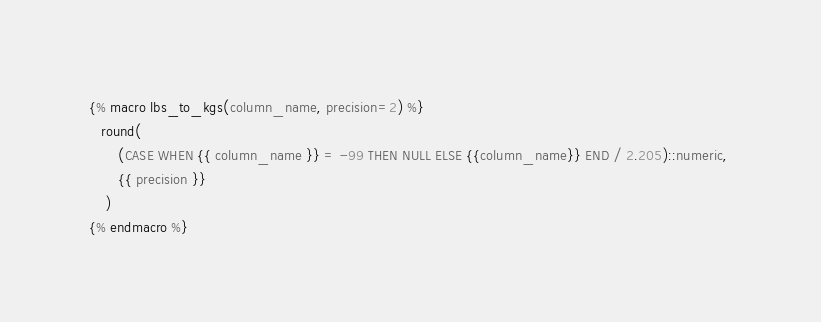<code> <loc_0><loc_0><loc_500><loc_500><_SQL_>{% macro lbs_to_kgs(column_name, precision=2) %}
   round(
       (CASE WHEN {{ column_name }} = -99 THEN NULL ELSE {{column_name}} END / 2.205)::numeric, 
       {{ precision }}
    )
{% endmacro %}</code> 